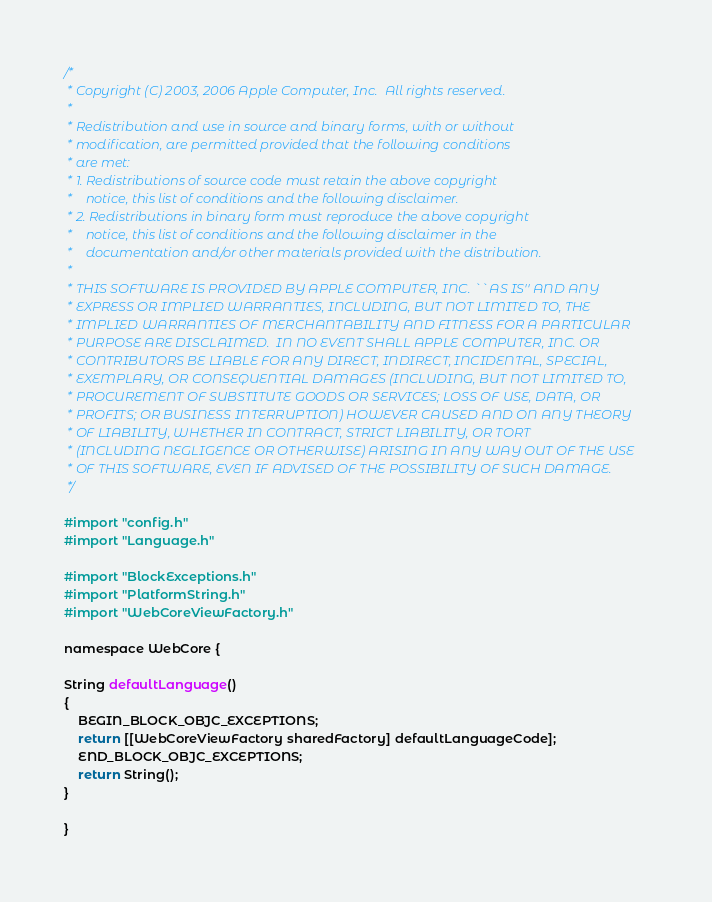<code> <loc_0><loc_0><loc_500><loc_500><_ObjectiveC_>/*
 * Copyright (C) 2003, 2006 Apple Computer, Inc.  All rights reserved.
 *
 * Redistribution and use in source and binary forms, with or without
 * modification, are permitted provided that the following conditions
 * are met:
 * 1. Redistributions of source code must retain the above copyright
 *    notice, this list of conditions and the following disclaimer.
 * 2. Redistributions in binary form must reproduce the above copyright
 *    notice, this list of conditions and the following disclaimer in the
 *    documentation and/or other materials provided with the distribution.
 *
 * THIS SOFTWARE IS PROVIDED BY APPLE COMPUTER, INC. ``AS IS'' AND ANY
 * EXPRESS OR IMPLIED WARRANTIES, INCLUDING, BUT NOT LIMITED TO, THE
 * IMPLIED WARRANTIES OF MERCHANTABILITY AND FITNESS FOR A PARTICULAR
 * PURPOSE ARE DISCLAIMED.  IN NO EVENT SHALL APPLE COMPUTER, INC. OR
 * CONTRIBUTORS BE LIABLE FOR ANY DIRECT, INDIRECT, INCIDENTAL, SPECIAL,
 * EXEMPLARY, OR CONSEQUENTIAL DAMAGES (INCLUDING, BUT NOT LIMITED TO,
 * PROCUREMENT OF SUBSTITUTE GOODS OR SERVICES; LOSS OF USE, DATA, OR
 * PROFITS; OR BUSINESS INTERRUPTION) HOWEVER CAUSED AND ON ANY THEORY
 * OF LIABILITY, WHETHER IN CONTRACT, STRICT LIABILITY, OR TORT
 * (INCLUDING NEGLIGENCE OR OTHERWISE) ARISING IN ANY WAY OUT OF THE USE
 * OF THIS SOFTWARE, EVEN IF ADVISED OF THE POSSIBILITY OF SUCH DAMAGE. 
 */

#import "config.h"
#import "Language.h"

#import "BlockExceptions.h"
#import "PlatformString.h"
#import "WebCoreViewFactory.h"

namespace WebCore {

String defaultLanguage()
{
    BEGIN_BLOCK_OBJC_EXCEPTIONS;
    return [[WebCoreViewFactory sharedFactory] defaultLanguageCode];
    END_BLOCK_OBJC_EXCEPTIONS;
    return String();
}

}
</code> 